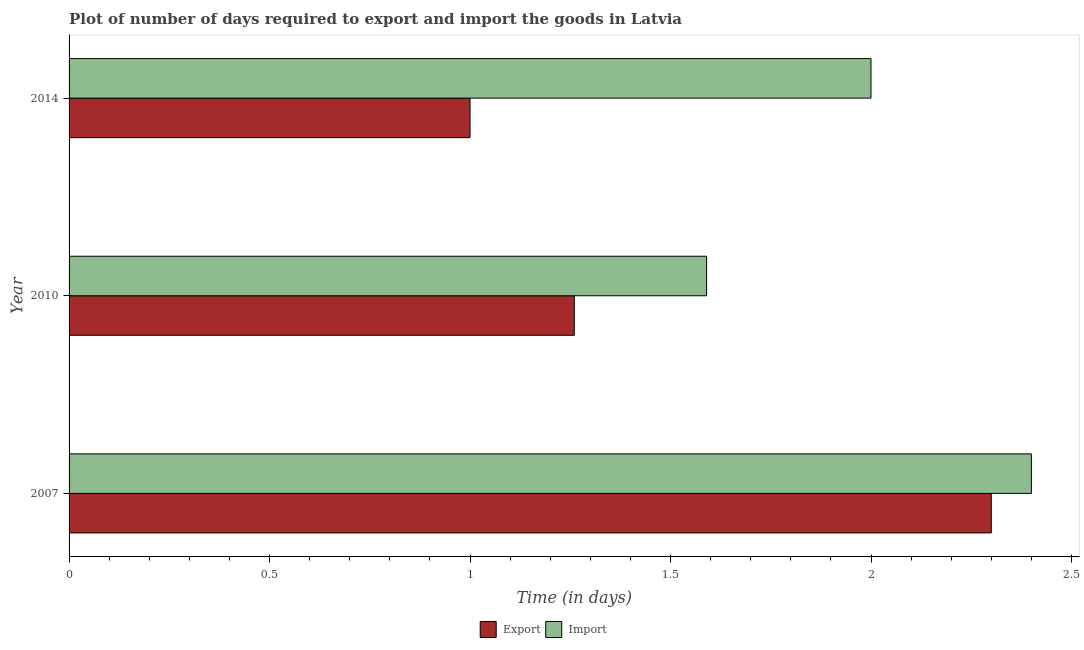Are the number of bars on each tick of the Y-axis equal?
Keep it short and to the point. Yes. How many bars are there on the 1st tick from the top?
Make the answer very short. 2. What is the label of the 1st group of bars from the top?
Your response must be concise. 2014. Across all years, what is the maximum time required to export?
Give a very brief answer. 2.3. Across all years, what is the minimum time required to import?
Make the answer very short. 1.59. What is the total time required to export in the graph?
Keep it short and to the point. 4.56. What is the difference between the time required to import in 2010 and that in 2014?
Offer a terse response. -0.41. What is the difference between the time required to import in 2010 and the time required to export in 2007?
Make the answer very short. -0.71. What is the average time required to import per year?
Give a very brief answer. 2. In the year 2010, what is the difference between the time required to import and time required to export?
Offer a terse response. 0.33. In how many years, is the time required to export greater than 0.7 days?
Your answer should be very brief. 3. What is the ratio of the time required to export in 2007 to that in 2010?
Give a very brief answer. 1.82. Is the time required to import in 2007 less than that in 2010?
Your response must be concise. No. What is the difference between the highest and the lowest time required to import?
Keep it short and to the point. 0.81. Is the sum of the time required to export in 2007 and 2010 greater than the maximum time required to import across all years?
Make the answer very short. Yes. What does the 2nd bar from the top in 2014 represents?
Offer a terse response. Export. What does the 2nd bar from the bottom in 2007 represents?
Provide a succinct answer. Import. How many bars are there?
Keep it short and to the point. 6. Are all the bars in the graph horizontal?
Give a very brief answer. Yes. How many years are there in the graph?
Offer a terse response. 3. What is the difference between two consecutive major ticks on the X-axis?
Offer a terse response. 0.5. What is the title of the graph?
Your answer should be very brief. Plot of number of days required to export and import the goods in Latvia. Does "Borrowers" appear as one of the legend labels in the graph?
Provide a succinct answer. No. What is the label or title of the X-axis?
Provide a succinct answer. Time (in days). What is the Time (in days) of Export in 2010?
Give a very brief answer. 1.26. What is the Time (in days) of Import in 2010?
Your response must be concise. 1.59. What is the Time (in days) of Export in 2014?
Keep it short and to the point. 1. Across all years, what is the minimum Time (in days) in Export?
Offer a very short reply. 1. Across all years, what is the minimum Time (in days) of Import?
Make the answer very short. 1.59. What is the total Time (in days) of Export in the graph?
Provide a succinct answer. 4.56. What is the total Time (in days) in Import in the graph?
Keep it short and to the point. 5.99. What is the difference between the Time (in days) of Export in 2007 and that in 2010?
Make the answer very short. 1.04. What is the difference between the Time (in days) in Import in 2007 and that in 2010?
Give a very brief answer. 0.81. What is the difference between the Time (in days) in Export in 2010 and that in 2014?
Your answer should be compact. 0.26. What is the difference between the Time (in days) in Import in 2010 and that in 2014?
Give a very brief answer. -0.41. What is the difference between the Time (in days) in Export in 2007 and the Time (in days) in Import in 2010?
Offer a very short reply. 0.71. What is the difference between the Time (in days) in Export in 2010 and the Time (in days) in Import in 2014?
Your answer should be very brief. -0.74. What is the average Time (in days) in Export per year?
Provide a succinct answer. 1.52. What is the average Time (in days) of Import per year?
Provide a succinct answer. 2. In the year 2007, what is the difference between the Time (in days) in Export and Time (in days) in Import?
Your response must be concise. -0.1. In the year 2010, what is the difference between the Time (in days) in Export and Time (in days) in Import?
Offer a very short reply. -0.33. What is the ratio of the Time (in days) of Export in 2007 to that in 2010?
Offer a terse response. 1.83. What is the ratio of the Time (in days) in Import in 2007 to that in 2010?
Keep it short and to the point. 1.51. What is the ratio of the Time (in days) of Export in 2010 to that in 2014?
Make the answer very short. 1.26. What is the ratio of the Time (in days) of Import in 2010 to that in 2014?
Your answer should be very brief. 0.8. What is the difference between the highest and the lowest Time (in days) in Export?
Give a very brief answer. 1.3. What is the difference between the highest and the lowest Time (in days) of Import?
Your response must be concise. 0.81. 